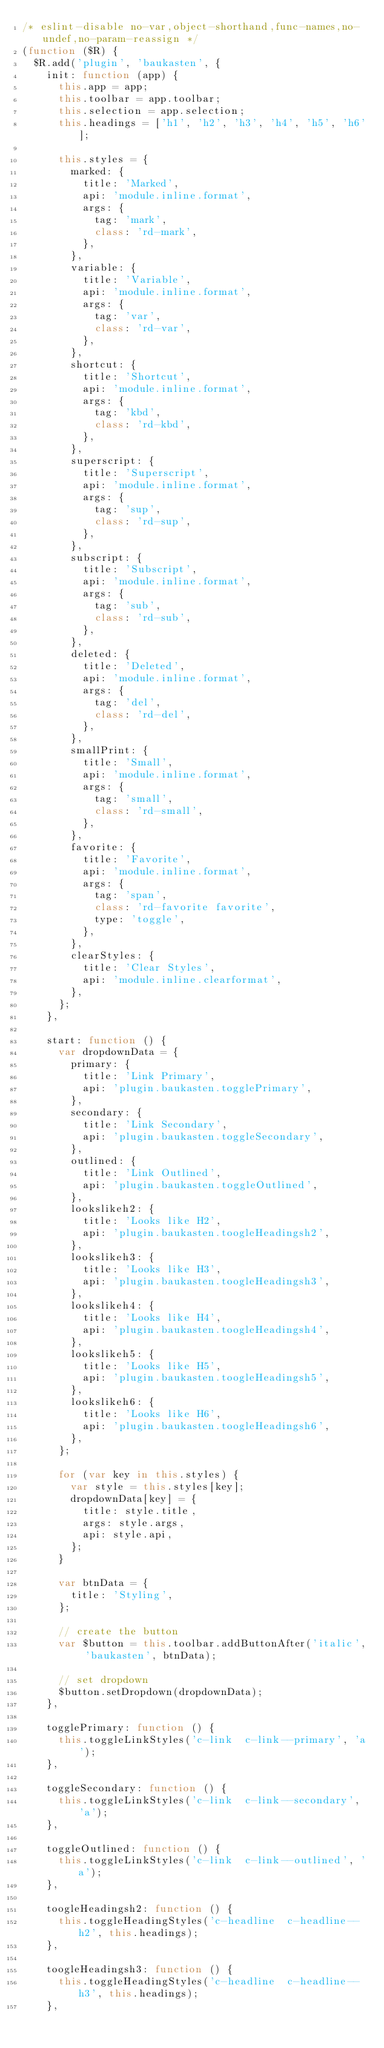<code> <loc_0><loc_0><loc_500><loc_500><_JavaScript_>/* eslint-disable no-var,object-shorthand,func-names,no-undef,no-param-reassign */
(function ($R) {
  $R.add('plugin', 'baukasten', {
    init: function (app) {
      this.app = app;
      this.toolbar = app.toolbar;
      this.selection = app.selection;
      this.headings = ['h1', 'h2', 'h3', 'h4', 'h5', 'h6'];

      this.styles = {
        marked: {
          title: 'Marked',
          api: 'module.inline.format',
          args: {
            tag: 'mark',
            class: 'rd-mark',
          },
        },
        variable: {
          title: 'Variable',
          api: 'module.inline.format',
          args: {
            tag: 'var',
            class: 'rd-var',
          },
        },
        shortcut: {
          title: 'Shortcut',
          api: 'module.inline.format',
          args: {
            tag: 'kbd',
            class: 'rd-kbd',
          },
        },
        superscript: {
          title: 'Superscript',
          api: 'module.inline.format',
          args: {
            tag: 'sup',
            class: 'rd-sup',
          },
        },
        subscript: {
          title: 'Subscript',
          api: 'module.inline.format',
          args: {
            tag: 'sub',
            class: 'rd-sub',
          },
        },
        deleted: {
          title: 'Deleted',
          api: 'module.inline.format',
          args: {
            tag: 'del',
            class: 'rd-del',
          },
        },
        smallPrint: {
          title: 'Small',
          api: 'module.inline.format',
          args: {
            tag: 'small',
            class: 'rd-small',
          },
        },
        favorite: {
          title: 'Favorite',
          api: 'module.inline.format',
          args: {
            tag: 'span',
            class: 'rd-favorite favorite',
            type: 'toggle',
          },
        },
        clearStyles: {
          title: 'Clear Styles',
          api: 'module.inline.clearformat',
        },
      };
    },

    start: function () {
      var dropdownData = {
        primary: {
          title: 'Link Primary',
          api: 'plugin.baukasten.togglePrimary',
        },
        secondary: {
          title: 'Link Secondary',
          api: 'plugin.baukasten.toggleSecondary',
        },
        outlined: {
          title: 'Link Outlined',
          api: 'plugin.baukasten.toggleOutlined',
        },
        lookslikeh2: {
          title: 'Looks like H2',
          api: 'plugin.baukasten.toogleHeadingsh2',
        },
        lookslikeh3: {
          title: 'Looks like H3',
          api: 'plugin.baukasten.toogleHeadingsh3',
        },
        lookslikeh4: {
          title: 'Looks like H4',
          api: 'plugin.baukasten.toogleHeadingsh4',
        },
        lookslikeh5: {
          title: 'Looks like H5',
          api: 'plugin.baukasten.toogleHeadingsh5',
        },
        lookslikeh6: {
          title: 'Looks like H6',
          api: 'plugin.baukasten.toogleHeadingsh6',
        },
      };

      for (var key in this.styles) {
        var style = this.styles[key];
        dropdownData[key] = {
          title: style.title,
          args: style.args,
          api: style.api,
        };
      }

      var btnData = {
        title: 'Styling',
      };

      // create the button
      var $button = this.toolbar.addButtonAfter('italic', 'baukasten', btnData);

      // set dropdown
      $button.setDropdown(dropdownData);
    },

    togglePrimary: function () {
      this.toggleLinkStyles('c-link  c-link--primary', 'a');
    },

    toggleSecondary: function () {
      this.toggleLinkStyles('c-link  c-link--secondary', 'a');
    },

    toggleOutlined: function () {
      this.toggleLinkStyles('c-link  c-link--outlined', 'a');
    },

    toogleHeadingsh2: function () {
      this.toggleHeadingStyles('c-headline  c-headline--h2', this.headings);
    },

    toogleHeadingsh3: function () {
      this.toggleHeadingStyles('c-headline  c-headline--h3', this.headings);
    },
</code> 